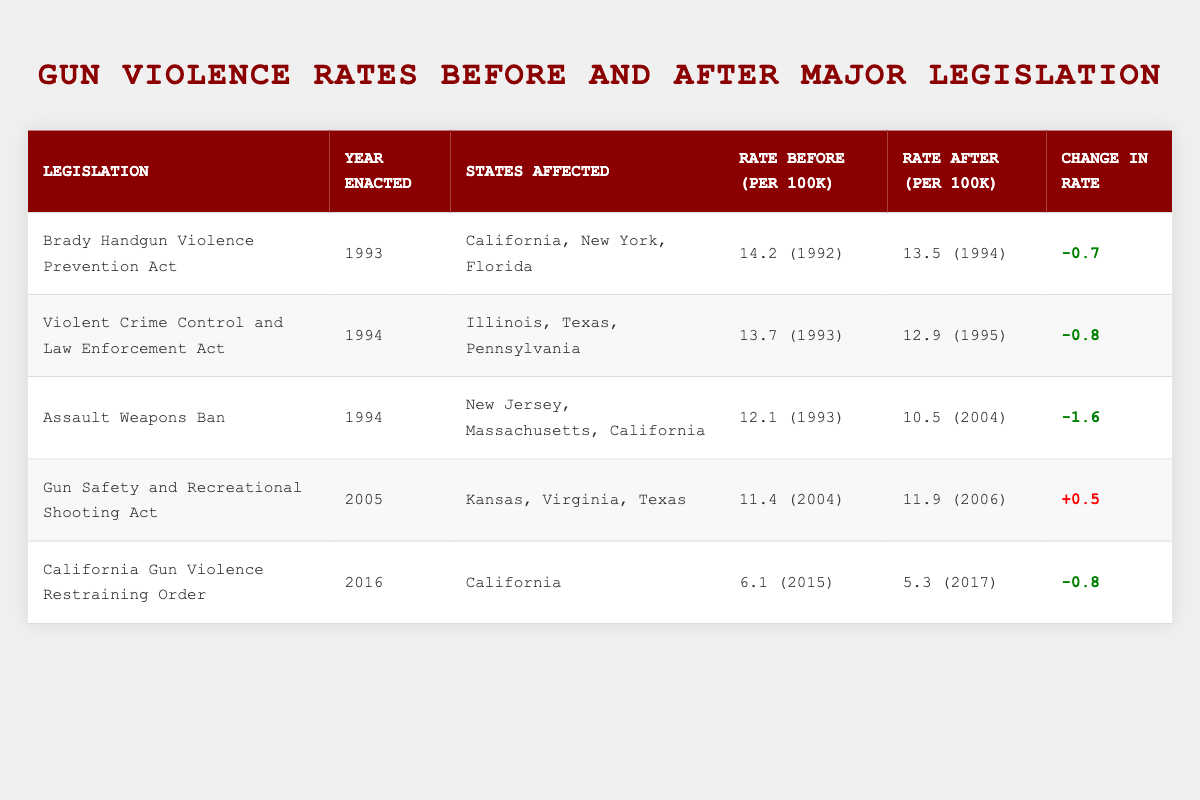What was the gun violence rate in California in 1992? The table indicates that the gun violence rate in California before the Brady Handgun Violence Prevention Act (enacted in 1993) was 14.2 per 100k in 1992.
Answer: 14.2 per 100k Which legislation had the lowest gun violence rate after its enactment? The table shows the rates after the enactment of each legislation. The California Gun Violence Restraining Order had a rate of 5.3 per 100k after its enactment, which is the lowest compared to the others.
Answer: California Gun Violence Restraining Order Did the Gun Safety and Recreational Shooting Act lead to a decrease in gun violence rate? Looking at the table, the rate before the Gun Safety and Recreational Shooting Act was 11.4 per 100k in 2004 and increased to 11.9 per 100k in 2006, indicating a rise rather than a decrease.
Answer: No What is the overall change in gun violence rate from the Brady Handgun Violence Prevention Act to the Violent Crime Control and Law Enforcement Act? The Brady Handgun Violence Prevention Act had a rate decrease of -0.7 (from 14.2 to 13.5), while the Violent Crime Control and Law Enforcement Act also had a rate decrease of -0.8 (from 13.7 to 12.9). To find the overall change, we calculate 13.5 - 12.9 = 0.6 decrease overall.
Answer: 0.6 decrease Which legislation shows an increase in gun violence rate? The only legislation with an increased rate is the Gun Safety and Recreational Shooting Act, which went from 11.4 per 100k to 11.9 per 100k. Other legislations decreased their rates.
Answer: Gun Safety and Recreational Shooting Act What was the average gun violence rate before the enactment of legislation from the years given? To find the average rate before the enactment of all legislations, we take the rates: 14.2, 13.7, 12.1, 11.4, and 6.1. Add them up: 14.2 + 13.7 + 12.1 + 11.4 + 6.1 = 57.5. Then, divide by 5 (the number of data points) to get the average: 57.5 / 5 = 11.5.
Answer: 11.5 Is it true that all legislations resulted in a decrease in gun violence rates except for one? Based on the table, the Gun Safety and Recreational Shooting Act is the only legislation that resulted in an increase in gun violence rates, while the others led to decreases. Therefore, the statement is true.
Answer: True 